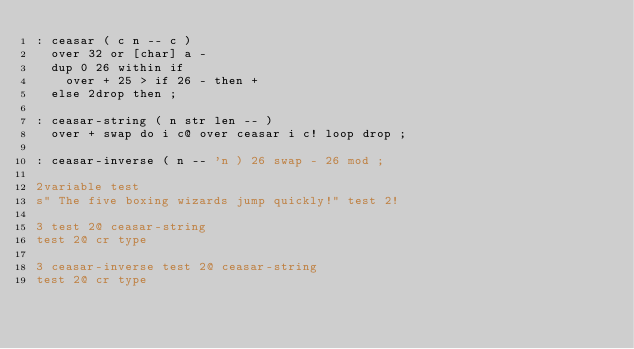<code> <loc_0><loc_0><loc_500><loc_500><_Forth_>: ceasar ( c n -- c )
  over 32 or [char] a -
  dup 0 26 within if
    over + 25 > if 26 - then +
  else 2drop then ;

: ceasar-string ( n str len -- )
  over + swap do i c@ over ceasar i c! loop drop ;

: ceasar-inverse ( n -- 'n ) 26 swap - 26 mod ;

2variable test
s" The five boxing wizards jump quickly!" test 2!

3 test 2@ ceasar-string
test 2@ cr type

3 ceasar-inverse test 2@ ceasar-string
test 2@ cr type
</code> 